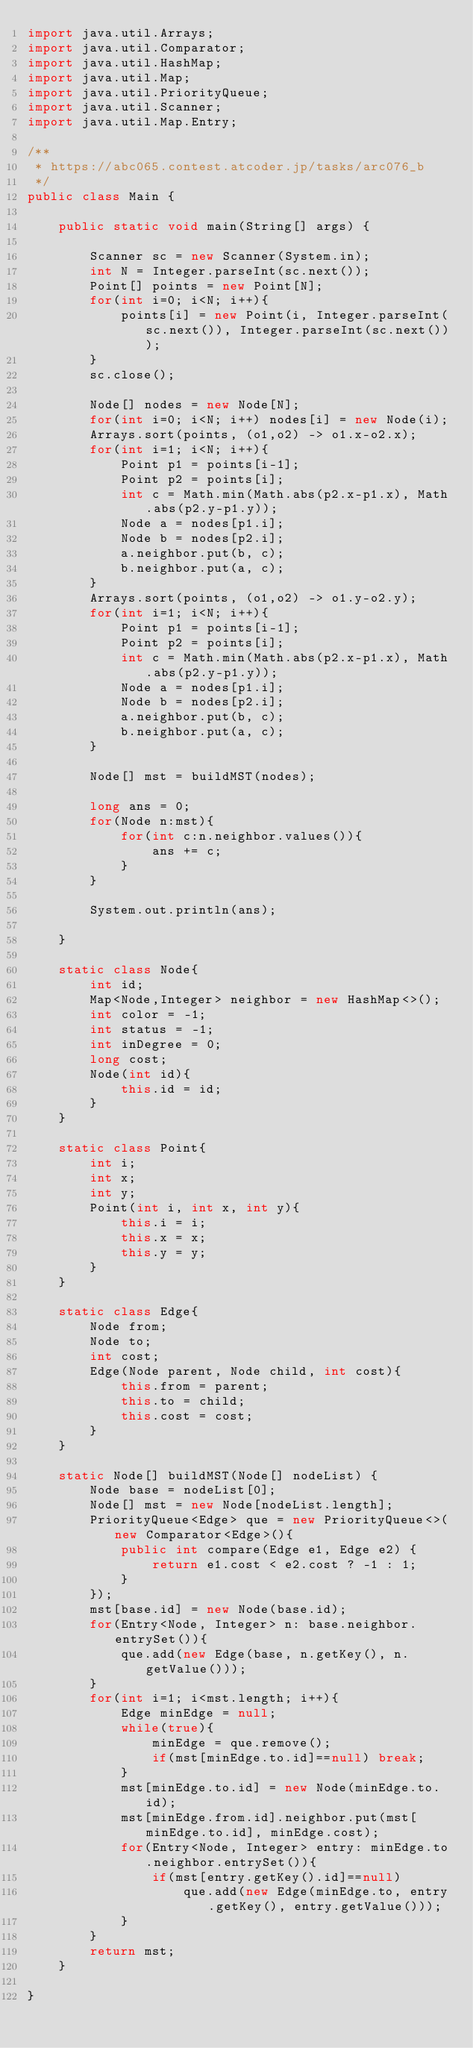<code> <loc_0><loc_0><loc_500><loc_500><_Java_>import java.util.Arrays;
import java.util.Comparator;
import java.util.HashMap;
import java.util.Map;
import java.util.PriorityQueue;
import java.util.Scanner;
import java.util.Map.Entry;

/**
 * https://abc065.contest.atcoder.jp/tasks/arc076_b
 */
public class Main {

	public static void main(String[] args) {
		
		Scanner sc = new Scanner(System.in);
		int N = Integer.parseInt(sc.next());
		Point[] points = new Point[N];
		for(int i=0; i<N; i++){
			points[i] = new Point(i, Integer.parseInt(sc.next()), Integer.parseInt(sc.next()));
		}
		sc.close();
		
		Node[] nodes = new Node[N];
		for(int i=0; i<N; i++) nodes[i] = new Node(i);
		Arrays.sort(points, (o1,o2) -> o1.x-o2.x);
		for(int i=1; i<N; i++){
			Point p1 = points[i-1];
			Point p2 = points[i];
			int c = Math.min(Math.abs(p2.x-p1.x), Math.abs(p2.y-p1.y));
			Node a = nodes[p1.i];
			Node b = nodes[p2.i];
			a.neighbor.put(b, c);
			b.neighbor.put(a, c);
		}
		Arrays.sort(points, (o1,o2) -> o1.y-o2.y);
		for(int i=1; i<N; i++){
			Point p1 = points[i-1];
			Point p2 = points[i];
			int c = Math.min(Math.abs(p2.x-p1.x), Math.abs(p2.y-p1.y));
			Node a = nodes[p1.i];
			Node b = nodes[p2.i];
			a.neighbor.put(b, c);
			b.neighbor.put(a, c);
		}
		
		Node[] mst = buildMST(nodes);
		
		long ans = 0;
		for(Node n:mst){
			for(int c:n.neighbor.values()){
				ans += c;
			}
		}
		
		System.out.println(ans);
		
	}
	
	static class Node{
		int id;
		Map<Node,Integer> neighbor = new HashMap<>();
		int color = -1;
		int status = -1;
		int inDegree = 0;
		long cost;
		Node(int id){
			this.id = id;
		}
	}
	
	static class Point{
		int i;
		int x;
		int y;
		Point(int i, int x, int y){
			this.i = i;
			this.x = x;
			this.y = y;
		}
	}
	
	static class Edge{
		Node from;
		Node to;
		int cost;
		Edge(Node parent, Node child, int cost){
			this.from = parent;
			this.to = child;
			this.cost = cost;
		}
	}
	
	static Node[] buildMST(Node[] nodeList) {
		Node base = nodeList[0];
		Node[] mst = new Node[nodeList.length];
		PriorityQueue<Edge> que = new PriorityQueue<>(new Comparator<Edge>(){
			public int compare(Edge e1, Edge e2) {
				return e1.cost < e2.cost ? -1 : 1;
			}
		});
		mst[base.id] = new Node(base.id);
		for(Entry<Node, Integer> n: base.neighbor.entrySet()){
			que.add(new Edge(base, n.getKey(), n.getValue()));
		}
		for(int i=1; i<mst.length; i++){
			Edge minEdge = null;
			while(true){
				minEdge = que.remove();
				if(mst[minEdge.to.id]==null) break;
			}
			mst[minEdge.to.id] = new Node(minEdge.to.id);
			mst[minEdge.from.id].neighbor.put(mst[minEdge.to.id], minEdge.cost);
			for(Entry<Node, Integer> entry: minEdge.to.neighbor.entrySet()){
				if(mst[entry.getKey().id]==null)
					que.add(new Edge(minEdge.to, entry.getKey(), entry.getValue()));
			}
		}
		return mst;
	}

}</code> 